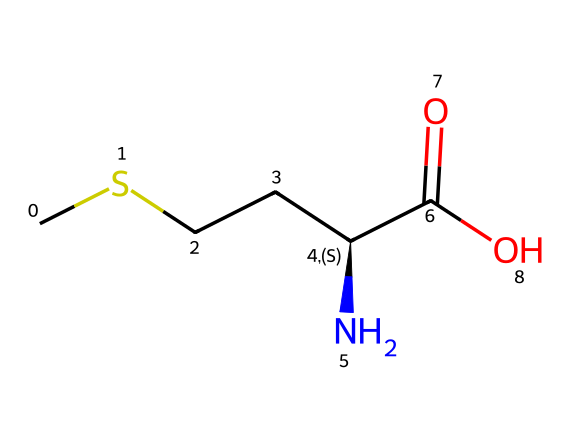What is the name of this compound? The compound represented by the SMILES is cysteine, which is a sulfur-containing amino acid. The presence of sulfur is indicated by the 'S' in the structure and the overall configuration is typical for amino acids.
Answer: cysteine How many hydrogen atoms are in this molecule? To find the number of hydrogen atoms, we analyze the structure: there are 3 hydrogen atoms connected to the carbon chain, one on the amino group (-NH2), and one on the -COOH carboxyl group, totaling 7 hydrogen atoms.
Answer: 7 What functional group is present in this compound? The compound contains a carboxylic acid functional group (-COOH), which is evident from the -C(=O)O part of the structure. Additionally, it has an amino group (-NH2) indicating it is an amino acid.
Answer: carboxylic acid Which atom indicates the presence of sulfur in this compound? The atom that indicates the presence of sulfur is the 'S' in the chemical structure. It is directly connected to the carbon chain, characteristic of sulfur-containing amino acids.
Answer: S How many chiral centers are present in this compound? The molecule has one chiral center, which is the carbon atom that is attached to the amino group, carboxyl group, a sulfur atom, and the rest of the carbon chain. This asymmetry defines its chirality.
Answer: 1 What type of reaction would this compound typically undergo in the body? Cysteine can undergo redox reactions due to the thiol group (-SH), which can be oxidized to form disulfide bonds, an important reaction in protein structure and regulation.
Answer: redox reactions 